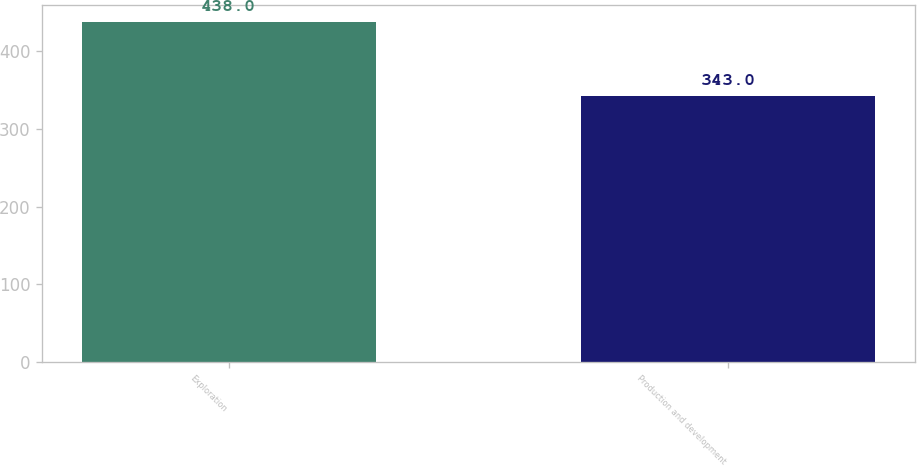Convert chart to OTSL. <chart><loc_0><loc_0><loc_500><loc_500><bar_chart><fcel>Exploration<fcel>Production and development<nl><fcel>438<fcel>343<nl></chart> 